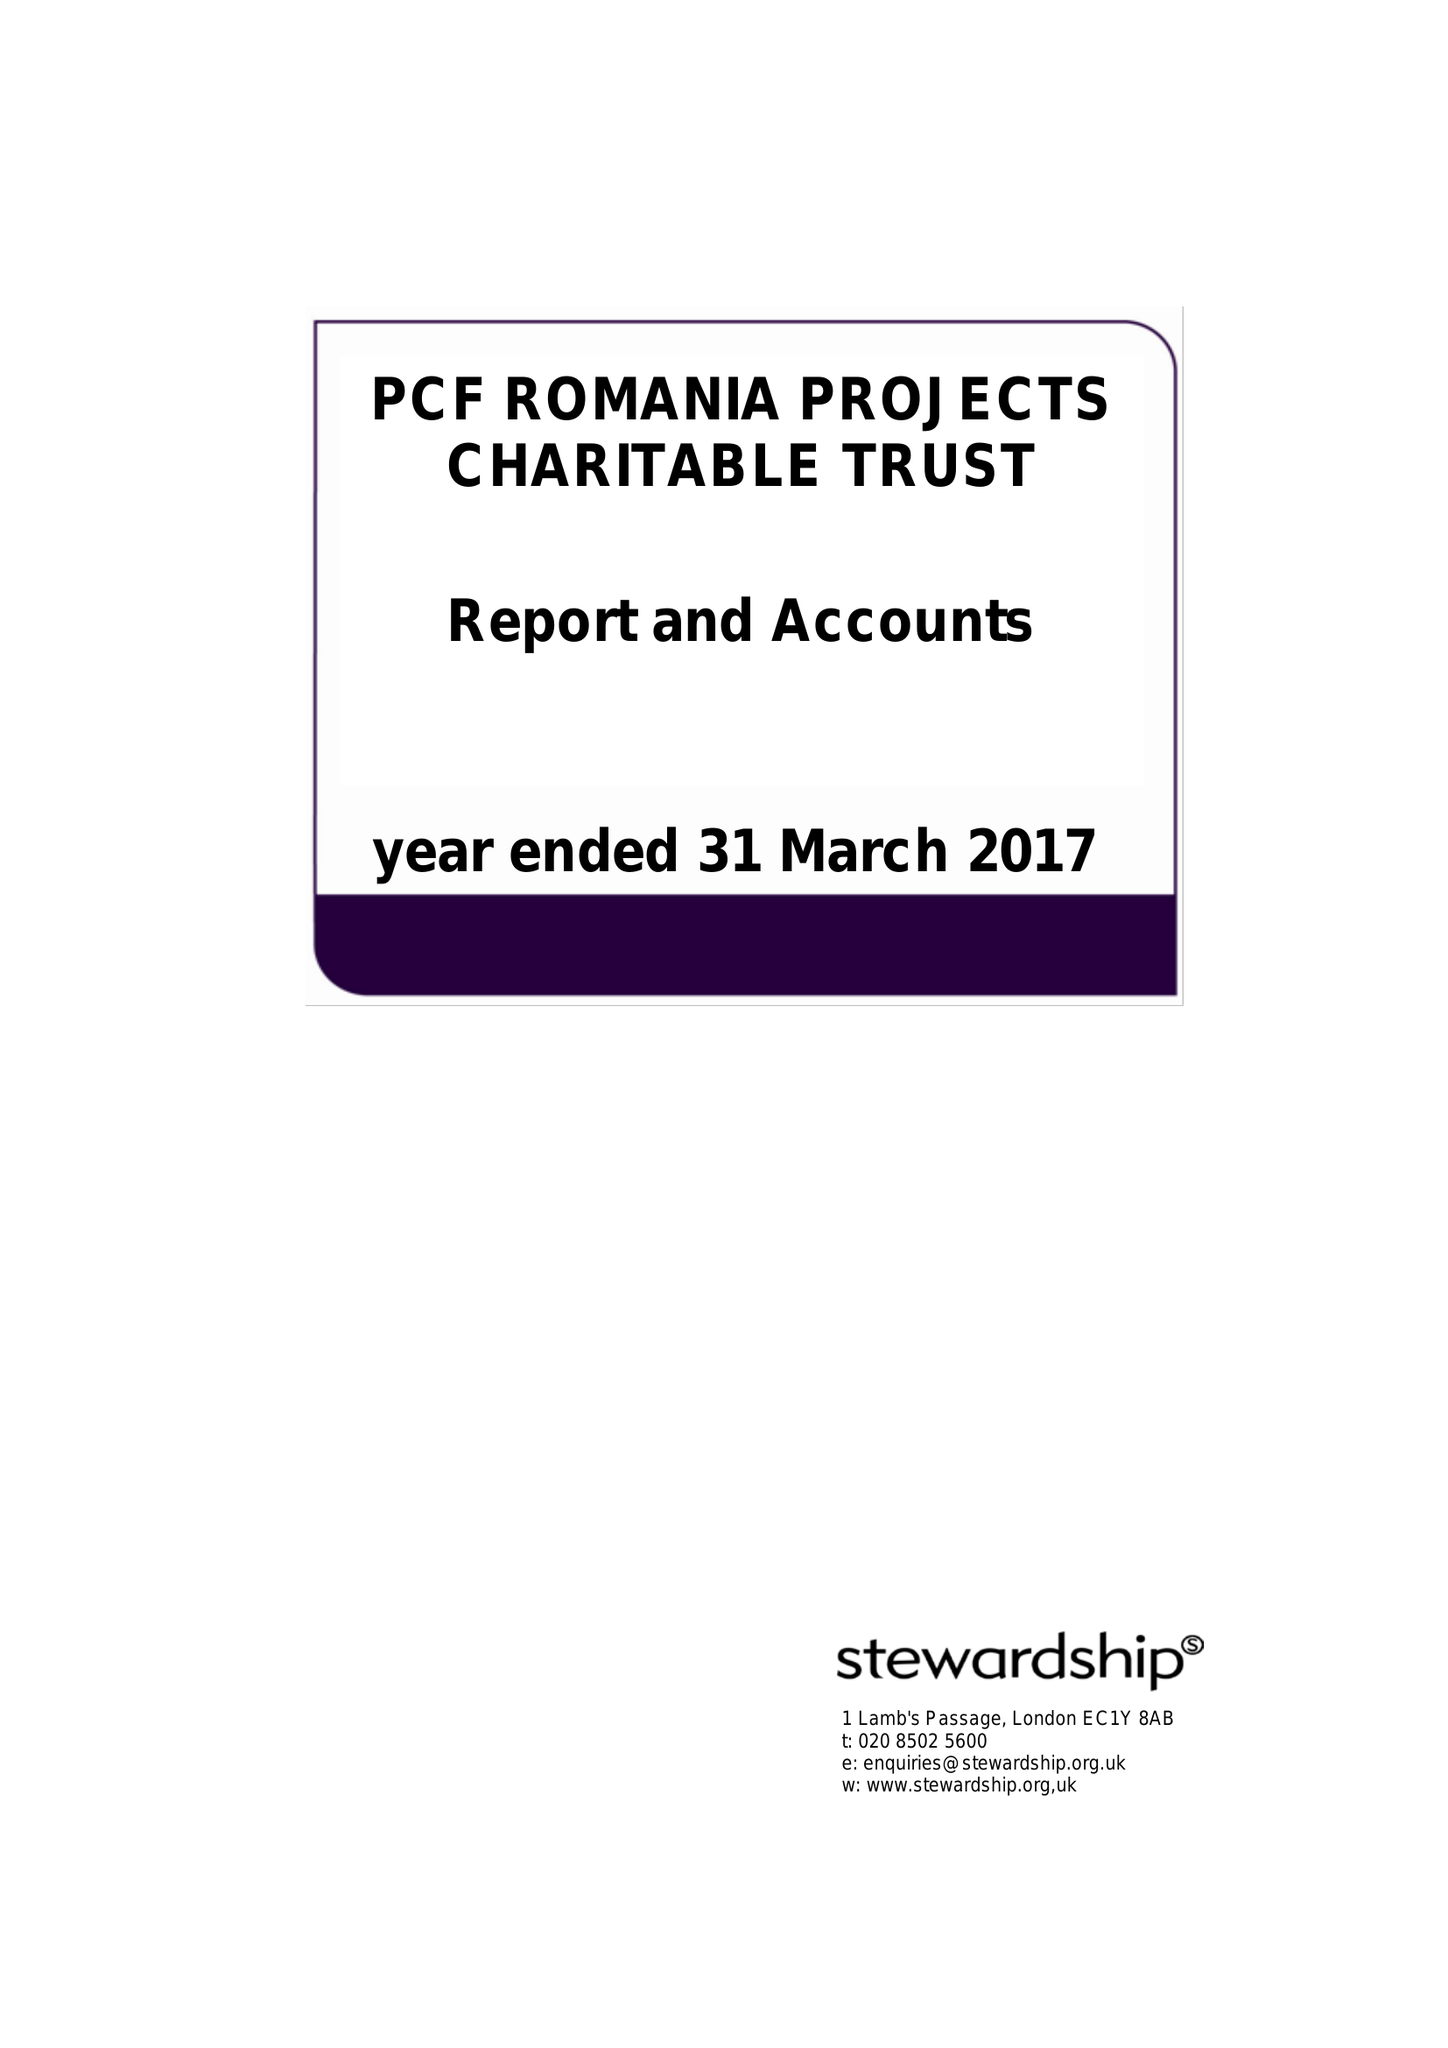What is the value for the address__postcode?
Answer the question using a single word or phrase. WV6 7UP 